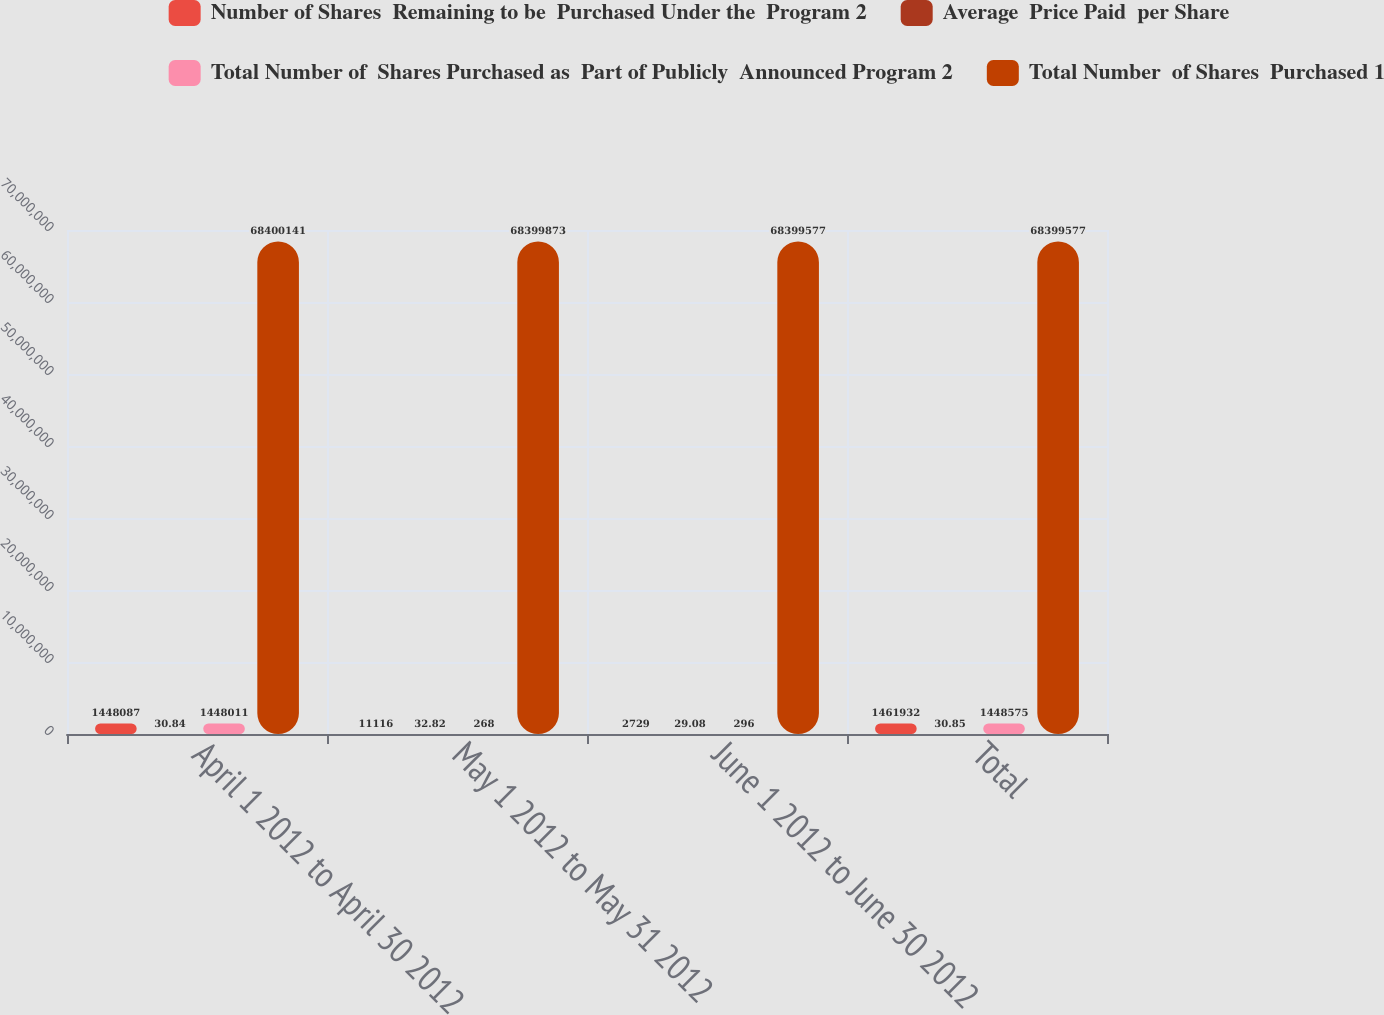Convert chart. <chart><loc_0><loc_0><loc_500><loc_500><stacked_bar_chart><ecel><fcel>April 1 2012 to April 30 2012<fcel>May 1 2012 to May 31 2012<fcel>June 1 2012 to June 30 2012<fcel>Total<nl><fcel>Number of Shares  Remaining to be  Purchased Under the  Program 2<fcel>1.44809e+06<fcel>11116<fcel>2729<fcel>1.46193e+06<nl><fcel>Average  Price Paid  per Share<fcel>30.84<fcel>32.82<fcel>29.08<fcel>30.85<nl><fcel>Total Number of  Shares Purchased as  Part of Publicly  Announced Program 2<fcel>1.44801e+06<fcel>268<fcel>296<fcel>1.44858e+06<nl><fcel>Total Number  of Shares  Purchased 1<fcel>6.84001e+07<fcel>6.83999e+07<fcel>6.83996e+07<fcel>6.83996e+07<nl></chart> 